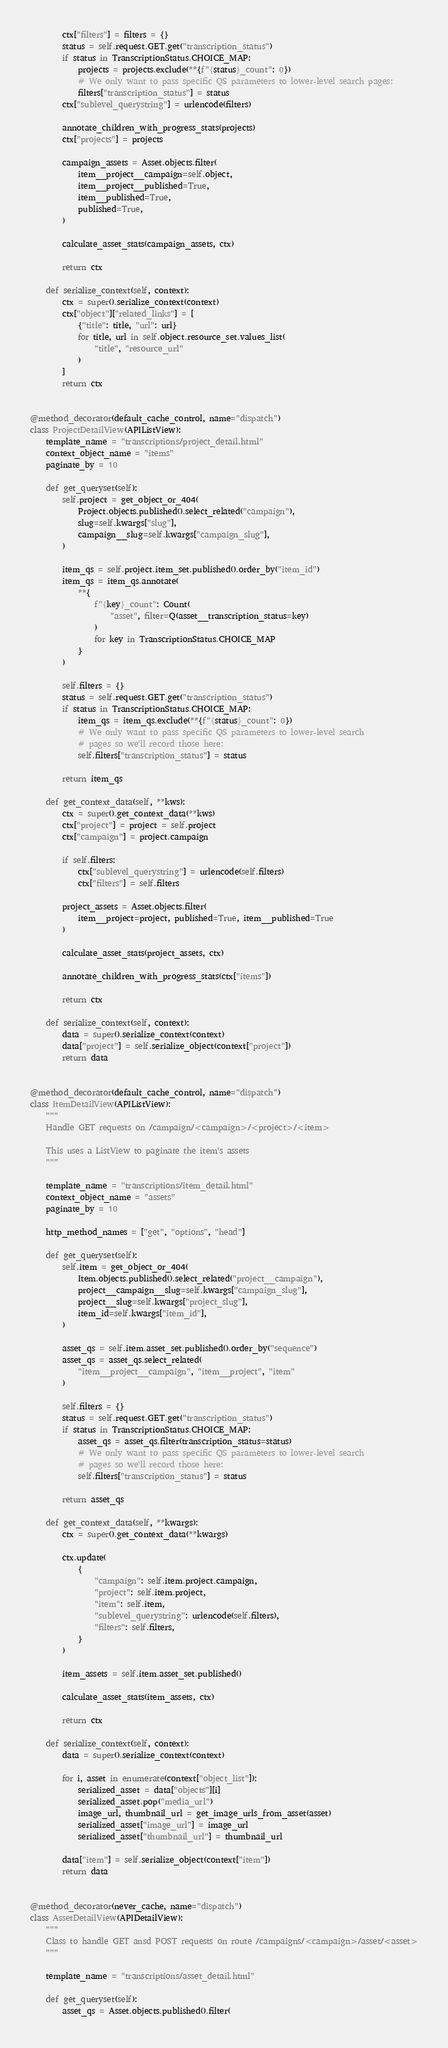Convert code to text. <code><loc_0><loc_0><loc_500><loc_500><_Python_>
        ctx["filters"] = filters = {}
        status = self.request.GET.get("transcription_status")
        if status in TranscriptionStatus.CHOICE_MAP:
            projects = projects.exclude(**{f"{status}_count": 0})
            # We only want to pass specific QS parameters to lower-level search pages:
            filters["transcription_status"] = status
        ctx["sublevel_querystring"] = urlencode(filters)

        annotate_children_with_progress_stats(projects)
        ctx["projects"] = projects

        campaign_assets = Asset.objects.filter(
            item__project__campaign=self.object,
            item__project__published=True,
            item__published=True,
            published=True,
        )

        calculate_asset_stats(campaign_assets, ctx)

        return ctx

    def serialize_context(self, context):
        ctx = super().serialize_context(context)
        ctx["object"]["related_links"] = [
            {"title": title, "url": url}
            for title, url in self.object.resource_set.values_list(
                "title", "resource_url"
            )
        ]
        return ctx


@method_decorator(default_cache_control, name="dispatch")
class ProjectDetailView(APIListView):
    template_name = "transcriptions/project_detail.html"
    context_object_name = "items"
    paginate_by = 10

    def get_queryset(self):
        self.project = get_object_or_404(
            Project.objects.published().select_related("campaign"),
            slug=self.kwargs["slug"],
            campaign__slug=self.kwargs["campaign_slug"],
        )

        item_qs = self.project.item_set.published().order_by("item_id")
        item_qs = item_qs.annotate(
            **{
                f"{key}_count": Count(
                    "asset", filter=Q(asset__transcription_status=key)
                )
                for key in TranscriptionStatus.CHOICE_MAP
            }
        )

        self.filters = {}
        status = self.request.GET.get("transcription_status")
        if status in TranscriptionStatus.CHOICE_MAP:
            item_qs = item_qs.exclude(**{f"{status}_count": 0})
            # We only want to pass specific QS parameters to lower-level search
            # pages so we'll record those here:
            self.filters["transcription_status"] = status

        return item_qs

    def get_context_data(self, **kws):
        ctx = super().get_context_data(**kws)
        ctx["project"] = project = self.project
        ctx["campaign"] = project.campaign

        if self.filters:
            ctx["sublevel_querystring"] = urlencode(self.filters)
            ctx["filters"] = self.filters

        project_assets = Asset.objects.filter(
            item__project=project, published=True, item__published=True
        )

        calculate_asset_stats(project_assets, ctx)

        annotate_children_with_progress_stats(ctx["items"])

        return ctx

    def serialize_context(self, context):
        data = super().serialize_context(context)
        data["project"] = self.serialize_object(context["project"])
        return data


@method_decorator(default_cache_control, name="dispatch")
class ItemDetailView(APIListView):
    """
    Handle GET requests on /campaign/<campaign>/<project>/<item>

    This uses a ListView to paginate the item's assets
    """

    template_name = "transcriptions/item_detail.html"
    context_object_name = "assets"
    paginate_by = 10

    http_method_names = ["get", "options", "head"]

    def get_queryset(self):
        self.item = get_object_or_404(
            Item.objects.published().select_related("project__campaign"),
            project__campaign__slug=self.kwargs["campaign_slug"],
            project__slug=self.kwargs["project_slug"],
            item_id=self.kwargs["item_id"],
        )

        asset_qs = self.item.asset_set.published().order_by("sequence")
        asset_qs = asset_qs.select_related(
            "item__project__campaign", "item__project", "item"
        )

        self.filters = {}
        status = self.request.GET.get("transcription_status")
        if status in TranscriptionStatus.CHOICE_MAP:
            asset_qs = asset_qs.filter(transcription_status=status)
            # We only want to pass specific QS parameters to lower-level search
            # pages so we'll record those here:
            self.filters["transcription_status"] = status

        return asset_qs

    def get_context_data(self, **kwargs):
        ctx = super().get_context_data(**kwargs)

        ctx.update(
            {
                "campaign": self.item.project.campaign,
                "project": self.item.project,
                "item": self.item,
                "sublevel_querystring": urlencode(self.filters),
                "filters": self.filters,
            }
        )

        item_assets = self.item.asset_set.published()

        calculate_asset_stats(item_assets, ctx)

        return ctx

    def serialize_context(self, context):
        data = super().serialize_context(context)

        for i, asset in enumerate(context["object_list"]):
            serialized_asset = data["objects"][i]
            serialized_asset.pop("media_url")
            image_url, thumbnail_url = get_image_urls_from_asset(asset)
            serialized_asset["image_url"] = image_url
            serialized_asset["thumbnail_url"] = thumbnail_url

        data["item"] = self.serialize_object(context["item"])
        return data


@method_decorator(never_cache, name="dispatch")
class AssetDetailView(APIDetailView):
    """
    Class to handle GET ansd POST requests on route /campaigns/<campaign>/asset/<asset>
    """

    template_name = "transcriptions/asset_detail.html"

    def get_queryset(self):
        asset_qs = Asset.objects.published().filter(</code> 